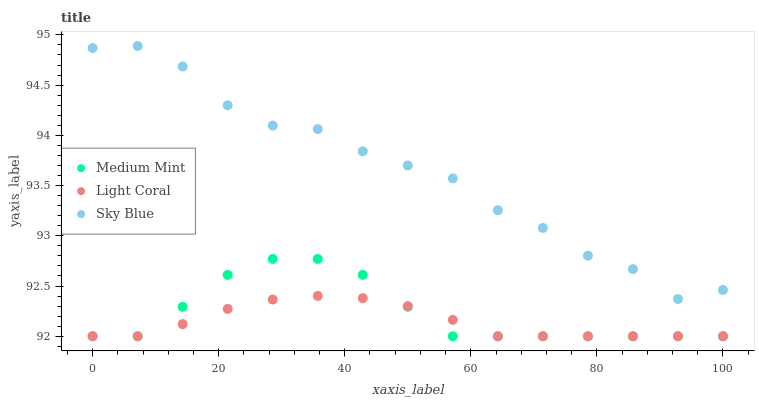Does Light Coral have the minimum area under the curve?
Answer yes or no. Yes. Does Sky Blue have the maximum area under the curve?
Answer yes or no. Yes. Does Sky Blue have the minimum area under the curve?
Answer yes or no. No. Does Light Coral have the maximum area under the curve?
Answer yes or no. No. Is Light Coral the smoothest?
Answer yes or no. Yes. Is Sky Blue the roughest?
Answer yes or no. Yes. Is Sky Blue the smoothest?
Answer yes or no. No. Is Light Coral the roughest?
Answer yes or no. No. Does Medium Mint have the lowest value?
Answer yes or no. Yes. Does Sky Blue have the lowest value?
Answer yes or no. No. Does Sky Blue have the highest value?
Answer yes or no. Yes. Does Light Coral have the highest value?
Answer yes or no. No. Is Medium Mint less than Sky Blue?
Answer yes or no. Yes. Is Sky Blue greater than Medium Mint?
Answer yes or no. Yes. Does Light Coral intersect Medium Mint?
Answer yes or no. Yes. Is Light Coral less than Medium Mint?
Answer yes or no. No. Is Light Coral greater than Medium Mint?
Answer yes or no. No. Does Medium Mint intersect Sky Blue?
Answer yes or no. No. 